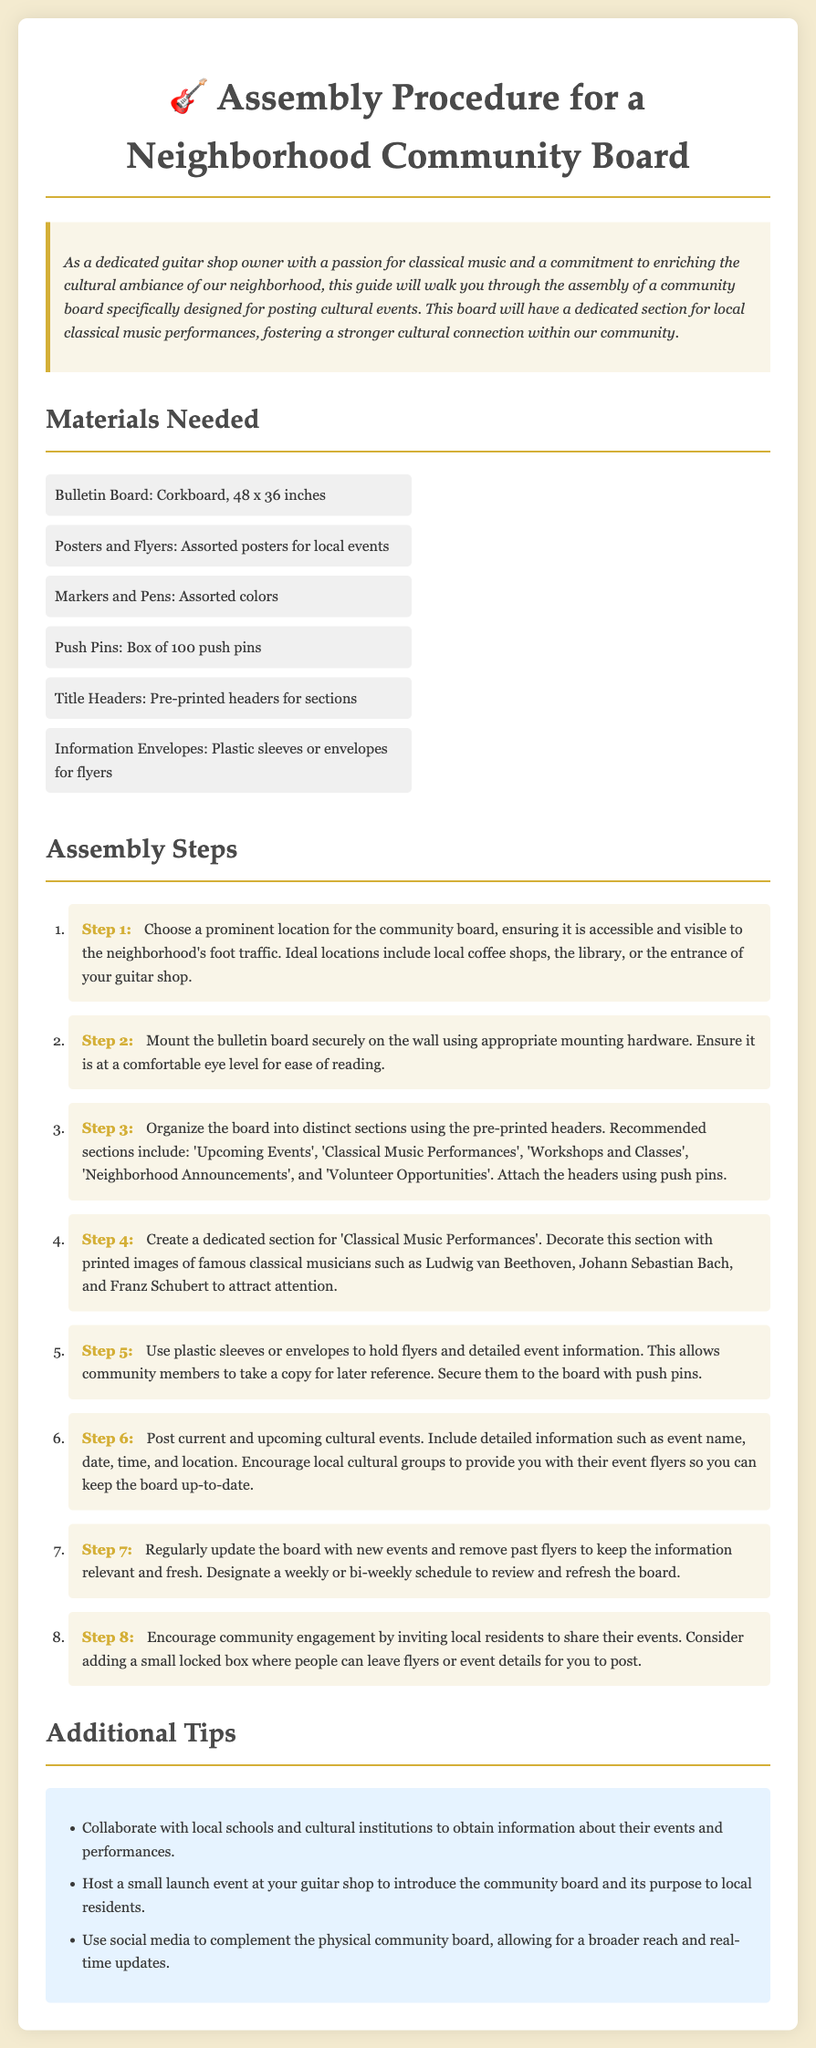What is the size of the bulletin board? The documents states that the bulletin board is 48 x 36 inches.
Answer: 48 x 36 inches What section is dedicated to local classical music performances? The document specifies the section titled 'Classical Music Performances' for posting related events.
Answer: Classical Music Performances How many materials are listed? There are a total of six materials needed for assembly as detailed in the 'Materials Needed' section.
Answer: 6 What step involves posting current events? Step 6 describes the process of posting current and upcoming cultural events.
Answer: Step 6 What color is the background of the document? The document mentions the background color as #f4ebd0 in the style section.
Answer: #f4ebd0 Which types of groups are encouraged to share their events? Local cultural groups are encouraged to provide their event flyers for posting.
Answer: Local cultural groups What is one way to engage the community according to the additional tips? One suggestion is to add a small locked box for residents to leave flyers or event details.
Answer: Small locked box What should be used to hold flyers for easier reference? Plastic sleeves or envelopes are recommended to hold flyers and detailed event information.
Answer: Plastic sleeves or envelopes What are the ideal locations for placing the community board? Ideal locations suggested include local coffee shops, the library, or the entrance of your guitar shop.
Answer: Local coffee shops, the library, the entrance of your guitar shop 